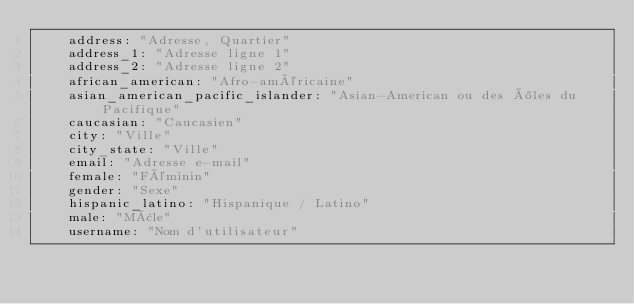<code> <loc_0><loc_0><loc_500><loc_500><_YAML_>    address: "Adresse, Quartier"
    address_1: "Adresse ligne 1"
    address_2: "Adresse ligne 2"
    african_american: "Afro-américaine"
    asian_american_pacific_islander: "Asian-American ou des îles du Pacifique"
    caucasian: "Caucasien"
    city: "Ville"
    city_state: "Ville"
    email: "Adresse e-mail"
    female: "Féminin"
    gender: "Sexe"
    hispanic_latino: "Hispanique / Latino"
    male: "Mâle"
    username: "Nom d'utilisateur"</code> 